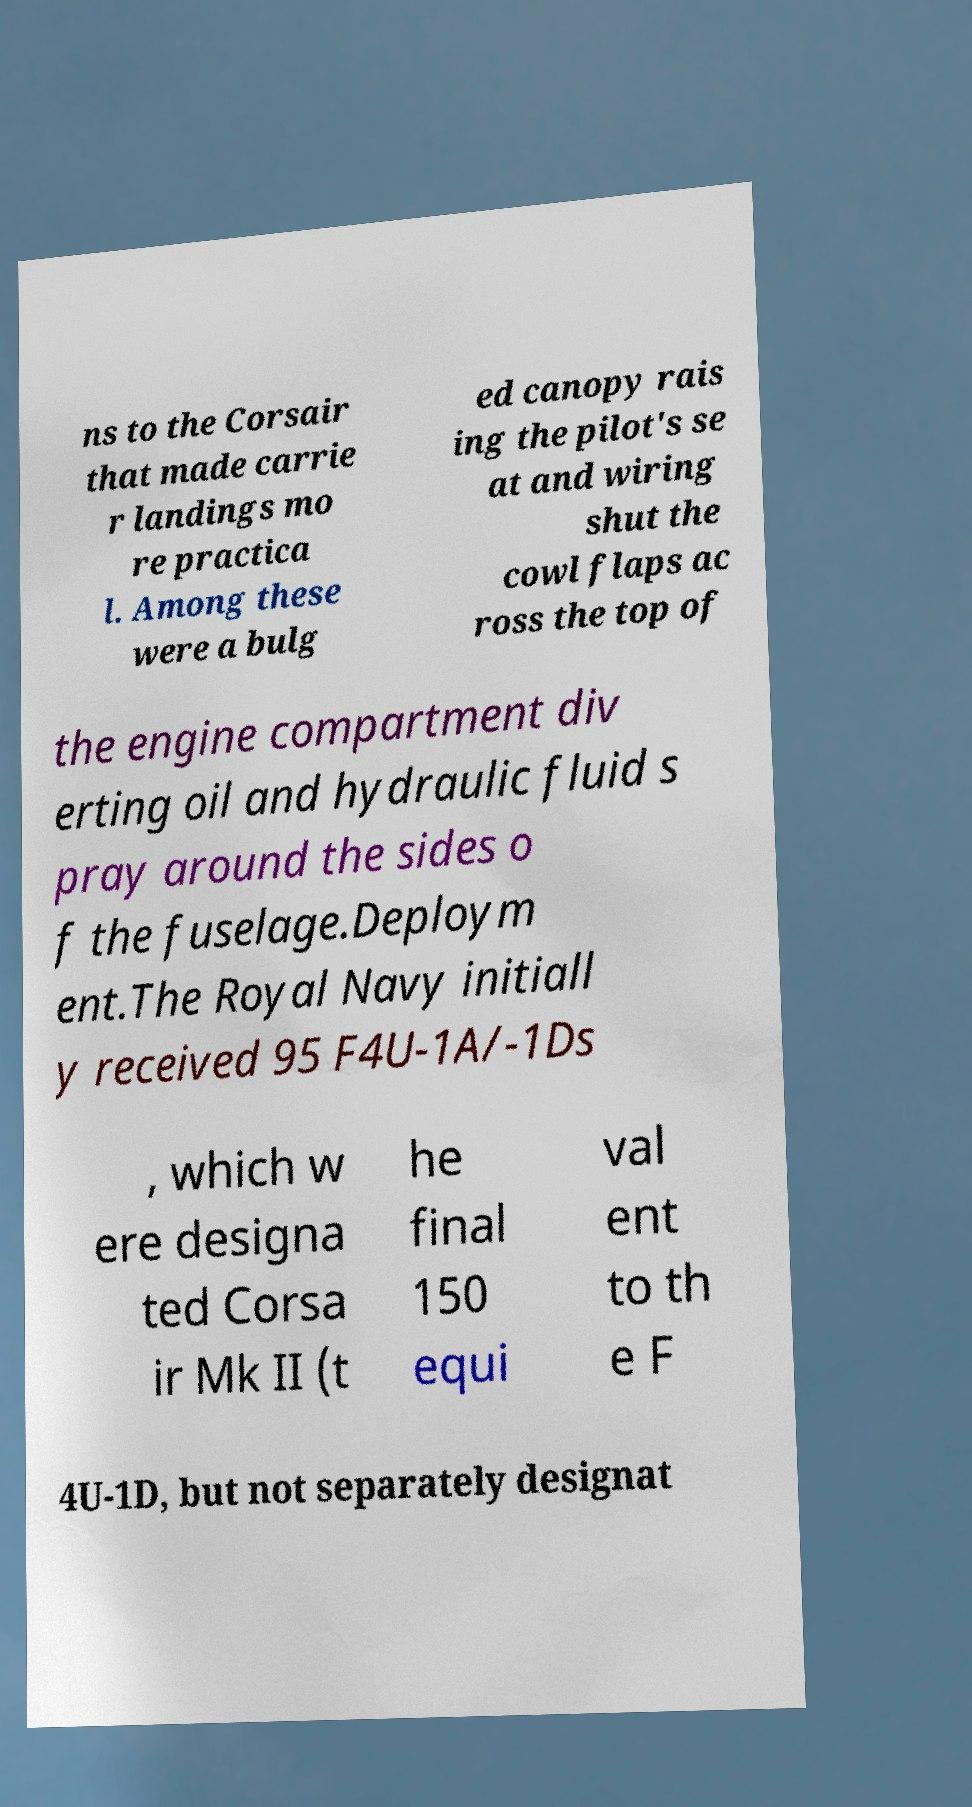Could you extract and type out the text from this image? ns to the Corsair that made carrie r landings mo re practica l. Among these were a bulg ed canopy rais ing the pilot's se at and wiring shut the cowl flaps ac ross the top of the engine compartment div erting oil and hydraulic fluid s pray around the sides o f the fuselage.Deploym ent.The Royal Navy initiall y received 95 F4U-1A/-1Ds , which w ere designa ted Corsa ir Mk II (t he final 150 equi val ent to th e F 4U-1D, but not separately designat 